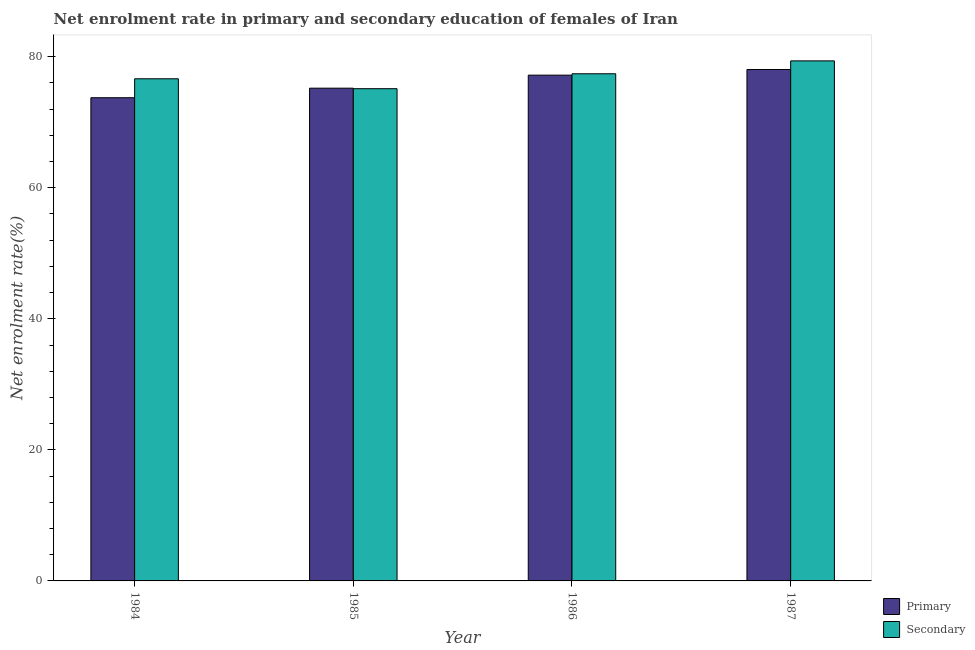How many different coloured bars are there?
Give a very brief answer. 2. Are the number of bars per tick equal to the number of legend labels?
Provide a short and direct response. Yes. What is the enrollment rate in primary education in 1984?
Give a very brief answer. 73.75. Across all years, what is the maximum enrollment rate in secondary education?
Keep it short and to the point. 79.37. Across all years, what is the minimum enrollment rate in secondary education?
Your response must be concise. 75.12. In which year was the enrollment rate in primary education minimum?
Provide a succinct answer. 1984. What is the total enrollment rate in secondary education in the graph?
Offer a terse response. 308.53. What is the difference between the enrollment rate in primary education in 1985 and that in 1987?
Give a very brief answer. -2.85. What is the difference between the enrollment rate in secondary education in 1984 and the enrollment rate in primary education in 1987?
Make the answer very short. -2.73. What is the average enrollment rate in secondary education per year?
Provide a short and direct response. 77.13. In the year 1984, what is the difference between the enrollment rate in secondary education and enrollment rate in primary education?
Keep it short and to the point. 0. In how many years, is the enrollment rate in primary education greater than 20 %?
Provide a succinct answer. 4. What is the ratio of the enrollment rate in primary education in 1984 to that in 1985?
Keep it short and to the point. 0.98. Is the enrollment rate in secondary education in 1984 less than that in 1986?
Your response must be concise. Yes. What is the difference between the highest and the second highest enrollment rate in secondary education?
Give a very brief answer. 1.97. What is the difference between the highest and the lowest enrollment rate in primary education?
Make the answer very short. 4.31. What does the 1st bar from the left in 1986 represents?
Give a very brief answer. Primary. What does the 2nd bar from the right in 1985 represents?
Provide a short and direct response. Primary. Are all the bars in the graph horizontal?
Your answer should be very brief. No. How many years are there in the graph?
Your answer should be very brief. 4. Does the graph contain grids?
Your response must be concise. No. What is the title of the graph?
Offer a very short reply. Net enrolment rate in primary and secondary education of females of Iran. Does "Agricultural land" appear as one of the legend labels in the graph?
Ensure brevity in your answer.  No. What is the label or title of the Y-axis?
Your response must be concise. Net enrolment rate(%). What is the Net enrolment rate(%) of Primary in 1984?
Provide a short and direct response. 73.75. What is the Net enrolment rate(%) in Secondary in 1984?
Provide a short and direct response. 76.64. What is the Net enrolment rate(%) of Primary in 1985?
Provide a short and direct response. 75.2. What is the Net enrolment rate(%) of Secondary in 1985?
Ensure brevity in your answer.  75.12. What is the Net enrolment rate(%) of Primary in 1986?
Your answer should be compact. 77.19. What is the Net enrolment rate(%) of Secondary in 1986?
Provide a short and direct response. 77.4. What is the Net enrolment rate(%) of Primary in 1987?
Make the answer very short. 78.05. What is the Net enrolment rate(%) in Secondary in 1987?
Give a very brief answer. 79.37. Across all years, what is the maximum Net enrolment rate(%) in Primary?
Offer a very short reply. 78.05. Across all years, what is the maximum Net enrolment rate(%) in Secondary?
Make the answer very short. 79.37. Across all years, what is the minimum Net enrolment rate(%) of Primary?
Offer a very short reply. 73.75. Across all years, what is the minimum Net enrolment rate(%) in Secondary?
Ensure brevity in your answer.  75.12. What is the total Net enrolment rate(%) in Primary in the graph?
Provide a succinct answer. 304.19. What is the total Net enrolment rate(%) in Secondary in the graph?
Keep it short and to the point. 308.53. What is the difference between the Net enrolment rate(%) of Primary in 1984 and that in 1985?
Offer a terse response. -1.46. What is the difference between the Net enrolment rate(%) in Secondary in 1984 and that in 1985?
Provide a succinct answer. 1.51. What is the difference between the Net enrolment rate(%) of Primary in 1984 and that in 1986?
Ensure brevity in your answer.  -3.45. What is the difference between the Net enrolment rate(%) in Secondary in 1984 and that in 1986?
Ensure brevity in your answer.  -0.76. What is the difference between the Net enrolment rate(%) in Primary in 1984 and that in 1987?
Provide a short and direct response. -4.31. What is the difference between the Net enrolment rate(%) in Secondary in 1984 and that in 1987?
Give a very brief answer. -2.73. What is the difference between the Net enrolment rate(%) in Primary in 1985 and that in 1986?
Provide a short and direct response. -1.99. What is the difference between the Net enrolment rate(%) of Secondary in 1985 and that in 1986?
Offer a terse response. -2.28. What is the difference between the Net enrolment rate(%) in Primary in 1985 and that in 1987?
Offer a terse response. -2.85. What is the difference between the Net enrolment rate(%) of Secondary in 1985 and that in 1987?
Offer a very short reply. -4.24. What is the difference between the Net enrolment rate(%) in Primary in 1986 and that in 1987?
Ensure brevity in your answer.  -0.86. What is the difference between the Net enrolment rate(%) of Secondary in 1986 and that in 1987?
Provide a succinct answer. -1.97. What is the difference between the Net enrolment rate(%) of Primary in 1984 and the Net enrolment rate(%) of Secondary in 1985?
Make the answer very short. -1.38. What is the difference between the Net enrolment rate(%) in Primary in 1984 and the Net enrolment rate(%) in Secondary in 1986?
Make the answer very short. -3.66. What is the difference between the Net enrolment rate(%) in Primary in 1984 and the Net enrolment rate(%) in Secondary in 1987?
Ensure brevity in your answer.  -5.62. What is the difference between the Net enrolment rate(%) of Primary in 1985 and the Net enrolment rate(%) of Secondary in 1986?
Your answer should be compact. -2.2. What is the difference between the Net enrolment rate(%) in Primary in 1985 and the Net enrolment rate(%) in Secondary in 1987?
Keep it short and to the point. -4.17. What is the difference between the Net enrolment rate(%) of Primary in 1986 and the Net enrolment rate(%) of Secondary in 1987?
Offer a very short reply. -2.18. What is the average Net enrolment rate(%) of Primary per year?
Ensure brevity in your answer.  76.05. What is the average Net enrolment rate(%) in Secondary per year?
Your answer should be very brief. 77.13. In the year 1984, what is the difference between the Net enrolment rate(%) of Primary and Net enrolment rate(%) of Secondary?
Provide a short and direct response. -2.89. In the year 1985, what is the difference between the Net enrolment rate(%) of Primary and Net enrolment rate(%) of Secondary?
Keep it short and to the point. 0.08. In the year 1986, what is the difference between the Net enrolment rate(%) in Primary and Net enrolment rate(%) in Secondary?
Provide a succinct answer. -0.21. In the year 1987, what is the difference between the Net enrolment rate(%) in Primary and Net enrolment rate(%) in Secondary?
Your response must be concise. -1.32. What is the ratio of the Net enrolment rate(%) of Primary in 1984 to that in 1985?
Ensure brevity in your answer.  0.98. What is the ratio of the Net enrolment rate(%) of Secondary in 1984 to that in 1985?
Your answer should be compact. 1.02. What is the ratio of the Net enrolment rate(%) in Primary in 1984 to that in 1986?
Make the answer very short. 0.96. What is the ratio of the Net enrolment rate(%) of Secondary in 1984 to that in 1986?
Provide a short and direct response. 0.99. What is the ratio of the Net enrolment rate(%) of Primary in 1984 to that in 1987?
Your response must be concise. 0.94. What is the ratio of the Net enrolment rate(%) in Secondary in 1984 to that in 1987?
Give a very brief answer. 0.97. What is the ratio of the Net enrolment rate(%) of Primary in 1985 to that in 1986?
Ensure brevity in your answer.  0.97. What is the ratio of the Net enrolment rate(%) in Secondary in 1985 to that in 1986?
Provide a short and direct response. 0.97. What is the ratio of the Net enrolment rate(%) in Primary in 1985 to that in 1987?
Your response must be concise. 0.96. What is the ratio of the Net enrolment rate(%) of Secondary in 1985 to that in 1987?
Keep it short and to the point. 0.95. What is the ratio of the Net enrolment rate(%) of Secondary in 1986 to that in 1987?
Offer a terse response. 0.98. What is the difference between the highest and the second highest Net enrolment rate(%) in Primary?
Ensure brevity in your answer.  0.86. What is the difference between the highest and the second highest Net enrolment rate(%) in Secondary?
Provide a short and direct response. 1.97. What is the difference between the highest and the lowest Net enrolment rate(%) in Primary?
Make the answer very short. 4.31. What is the difference between the highest and the lowest Net enrolment rate(%) in Secondary?
Provide a short and direct response. 4.24. 